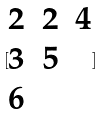<formula> <loc_0><loc_0><loc_500><loc_500>[ \begin{matrix} 2 & 2 & 4 \\ 3 & 5 \\ 6 \end{matrix} ]</formula> 